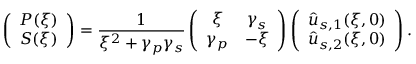Convert formula to latex. <formula><loc_0><loc_0><loc_500><loc_500>\left ( \begin{array} { c c } { P ( \xi ) } \\ { S ( \xi ) } \end{array} \right ) = \frac { 1 } { \xi ^ { 2 } + \gamma _ { p } \gamma _ { s } } \left ( \begin{array} { c c } { \xi } & { \gamma _ { s } } \\ { \gamma _ { p } } & { - \xi } \end{array} \right ) \left ( \begin{array} { c c } { \hat { u } _ { s , 1 } ( \xi , 0 ) } \\ { \hat { u } _ { s , 2 } ( \xi , 0 ) } \end{array} \right ) .</formula> 